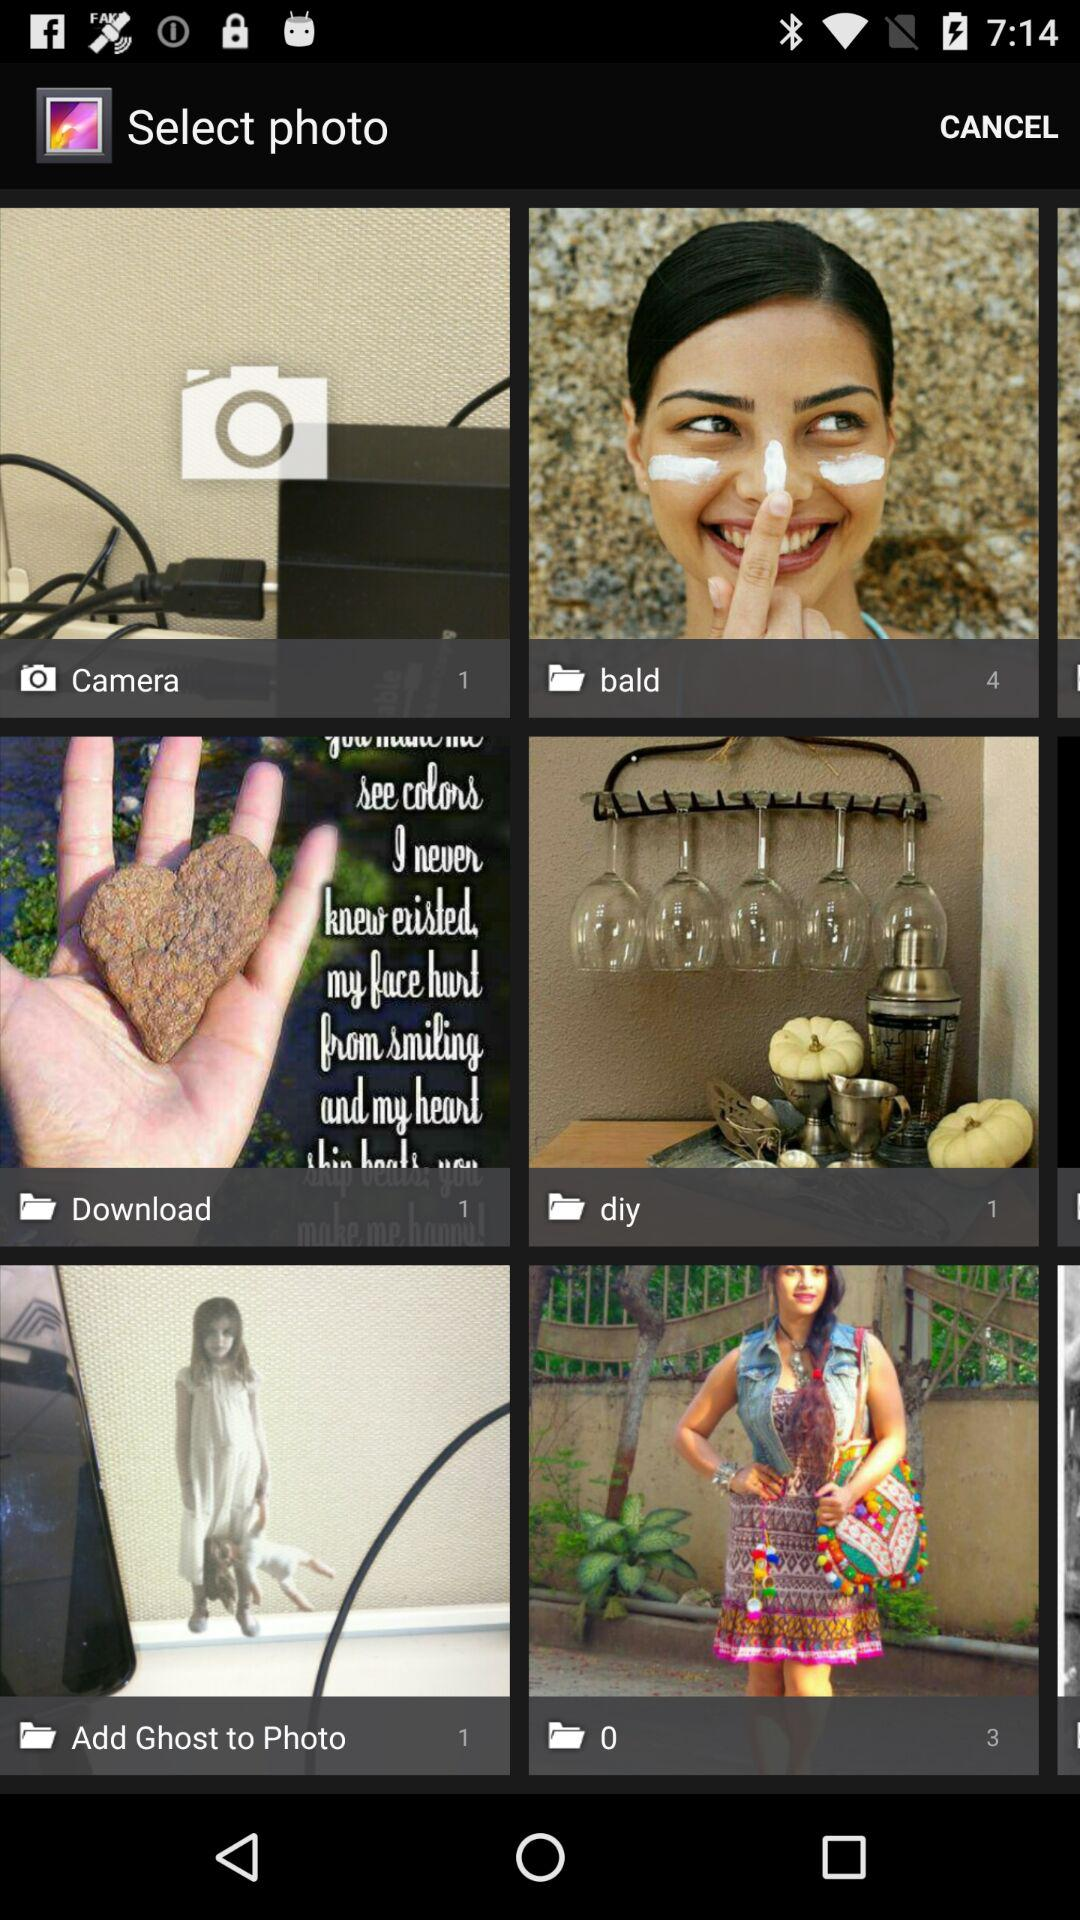How many photos are present in the "0" folder? There are 3 photos present in the "0" folder. 